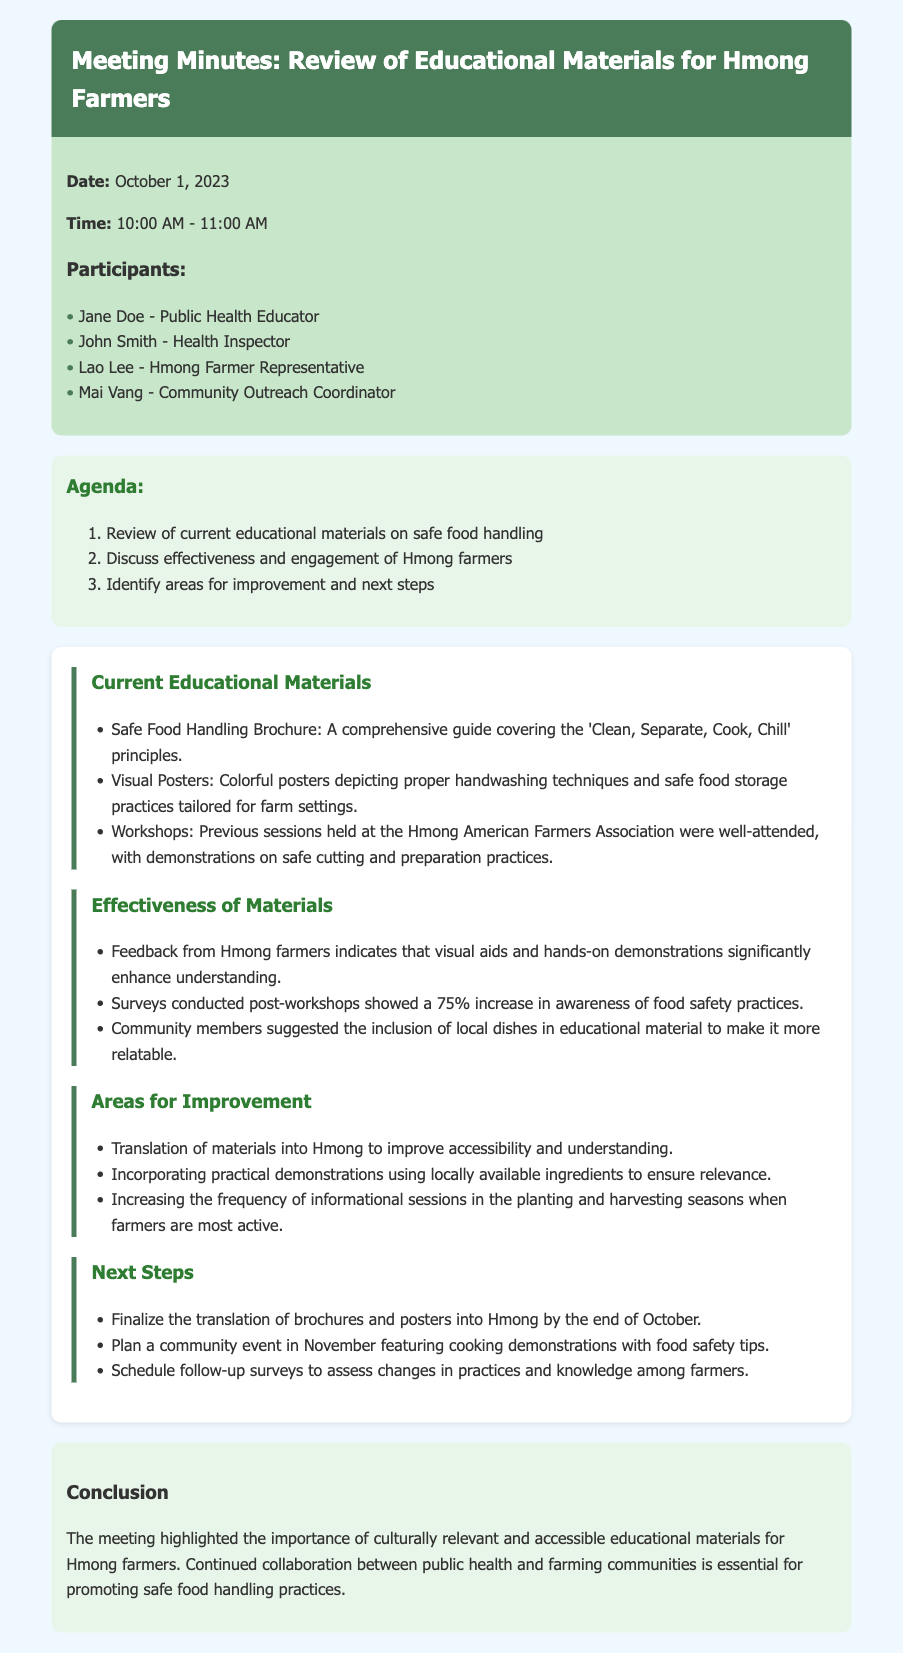what is the date of the meeting? The date of the meeting is explicitly stated in the meta info of the document.
Answer: October 1, 2023 who is the Public Health Educator present at the meeting? The list of participants includes the name of the Public Health Educator.
Answer: Jane Doe what percentage increase in awareness of food safety practices was noted after workshops? The document specifies the percentage increase in awareness reported in post-workshop surveys.
Answer: 75% which educational material was well-attended at the Hmong American Farmers Association? The discussion section mentions the type of session held that was well-attended.
Answer: Workshops what language is suggested for translating educational materials? The areas for improvement highlight the need for translation to enhance accessibility.
Answer: Hmong what type of community event is planned for November? The Next Steps section details the nature of the upcoming community event.
Answer: Cooking demonstrations what is one suggested area for improvement mentioned in the document? The document lists suggestions for enhancing the educational materials.
Answer: Translation of materials who is the Health Inspector mentioned in the participants list? The participants list provides the name of the Health Inspector involved in the meeting.
Answer: John Smith 